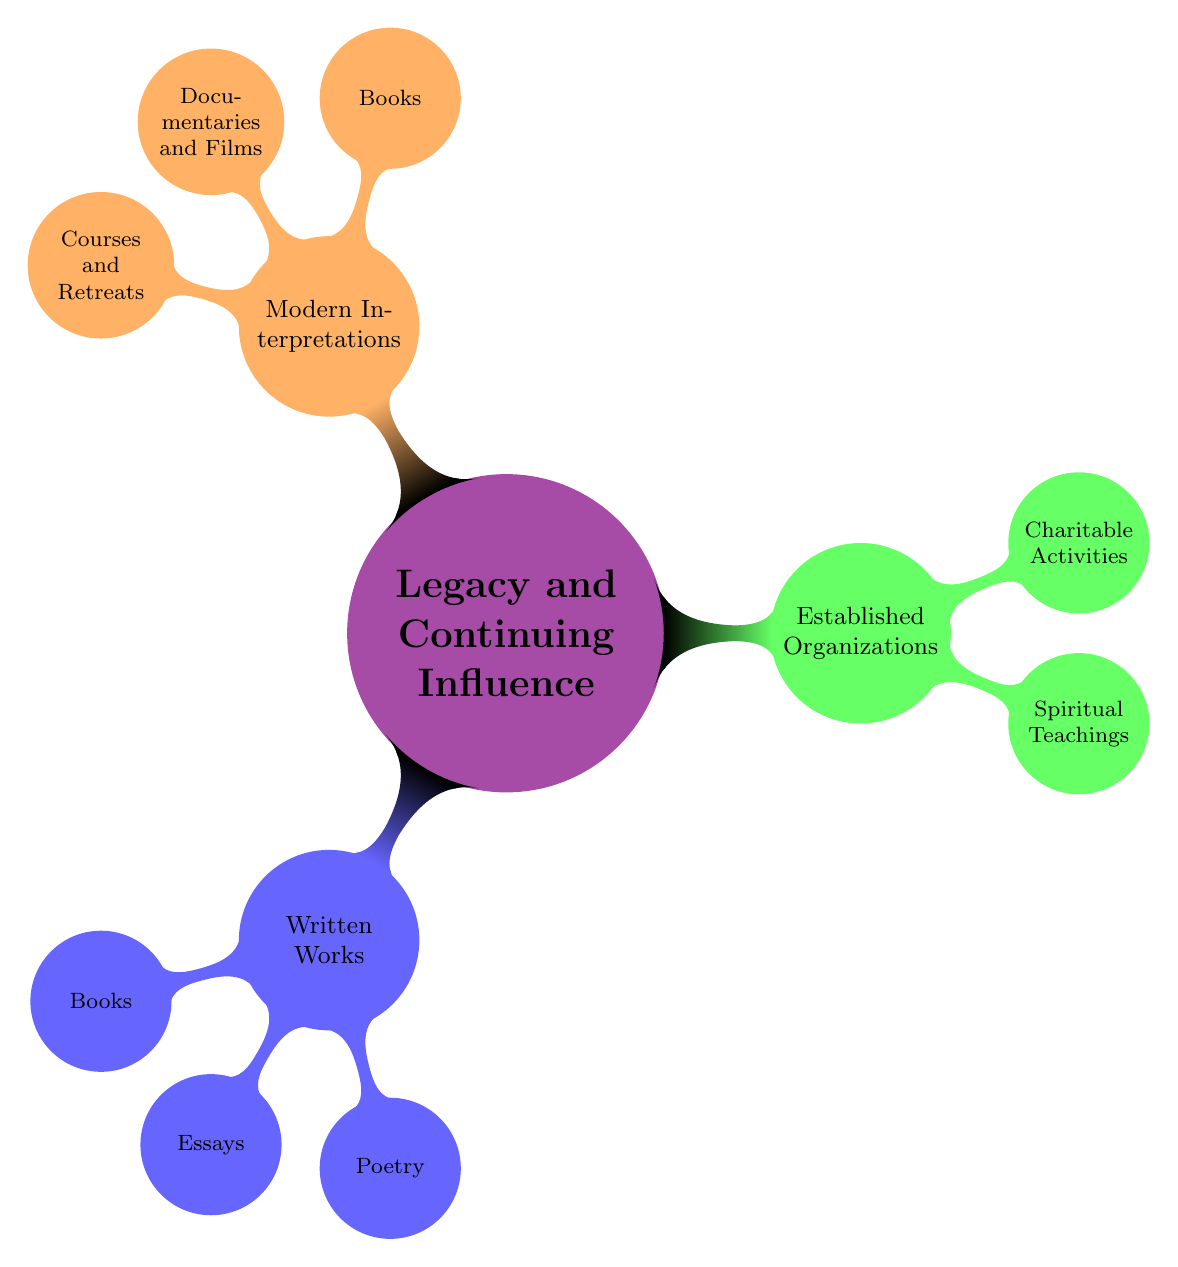What are the three main categories under "Legacy and Continuing Influence"? The main categories under "Legacy and Continuing Influence" are identified as "Written Works," "Established Organizations," and "Modern Interpretations." These categories are the primary branches stemming from the central theme.
Answer: Written Works, Established Organizations, Modern Interpretations How many types of written works are listed? The listed types of written works include "Books," "Essays," and "Poetry," making a total of three distinct types. This is determined by counting the nodes under the "Written Works" branch.
Answer: 3 Which category includes "Self-Realization Fellowship"? "Self-Realization Fellowship" belongs to the category of "Established Organizations," specifically under "Spiritual Teachings." This is inferred by tracing the hierarchy from the main node to the specific item mentioned.
Answer: Established Organizations Name one documentary listed in the "Modern Interpretations" category. One of the documentaries listed under "Modern Interpretations" is "Awake: The Life of Yogananda." This is found by navigating to the "Modern Interpretations" branch and selecting from the "Documentaries and Films" node.
Answer: Awake: The Life of Yogananda What is the total number of nodes in the "Written Works" category? The total number of nodes in the "Written Works" category is seven, which is calculated by counting the nodes under "Books" (3), "Essays" (2), and "Poetry" (2). Adding these gives a total of 3 + 2 + 2 = 7.
Answer: 7 Which type of modern interpretation includes "Vipassana Meditation Courses"? "Vipassana Meditation Courses" is included in the "Courses and Retreats" type within the "Modern Interpretations" category. This is identified by examining the child nodes under "Modern Interpretations."
Answer: Courses and Retreats How many charities are listed under "Established Organizations"? The number of charities listed under "Established Organizations" is three. This number is determined by counting the items under the "Charitable Activities" sub-branch.
Answer: 3 What is the primary focus of the "Charitable Activities" category? The primary focus of the "Charitable Activities" category is to highlight organizations that engage in charitable work. This is discerned through the node titles that are explicitly mentioned under this sub-category.
Answer: Charitable work 